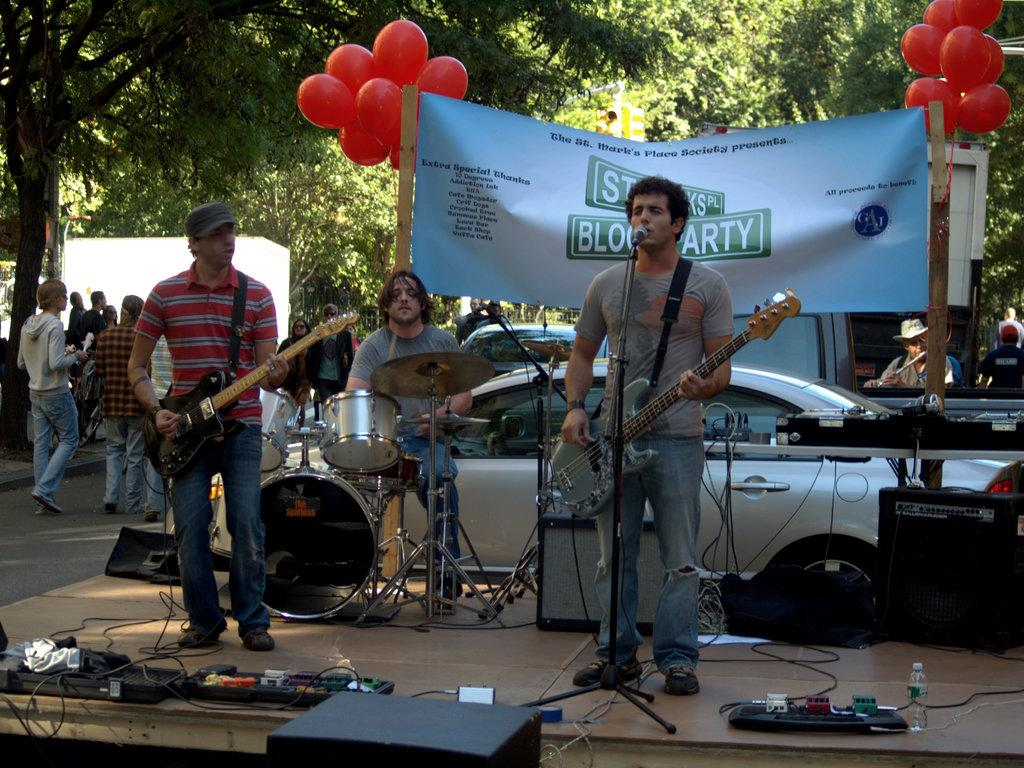What are the people in the image holding? The people in the image are holding musical instruments. What can be seen in the background of the image? In the background of the image, there are balloons, a banner, vehicles, trees, and people walking. Can you describe the banner in the background? The banner in the background is not described in the provided facts, so we cannot provide any details about it. What type of toy is being used as a guide for religious practices in the image? There is no toy or religious practice mentioned in the image, so we cannot answer this question. 